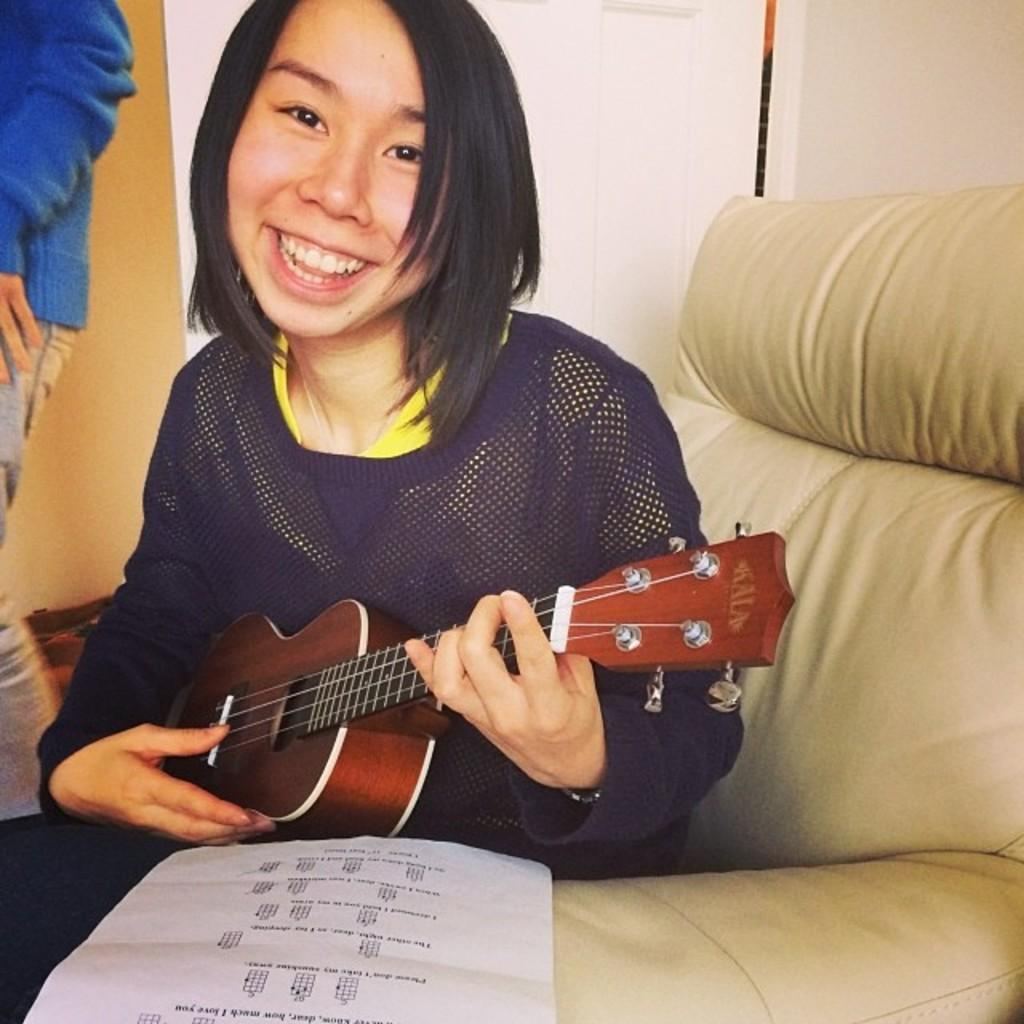Who is the main subject in the image? There is a woman in the image. What is the woman doing in the image? The woman is smiling and holding a guitar. Where is the woman sitting in the image? The woman is sitting on a sofa. What is placed in front of the woman? There is a paper in front of the woman. What can be seen in the background of the image? There is a wall in the background of the image. What caption is written on the guitar in the image? There is no caption written on the guitar in the image; it is just a guitar being held by the woman. How many chickens are visible in the image? There are no chickens present in the image. 